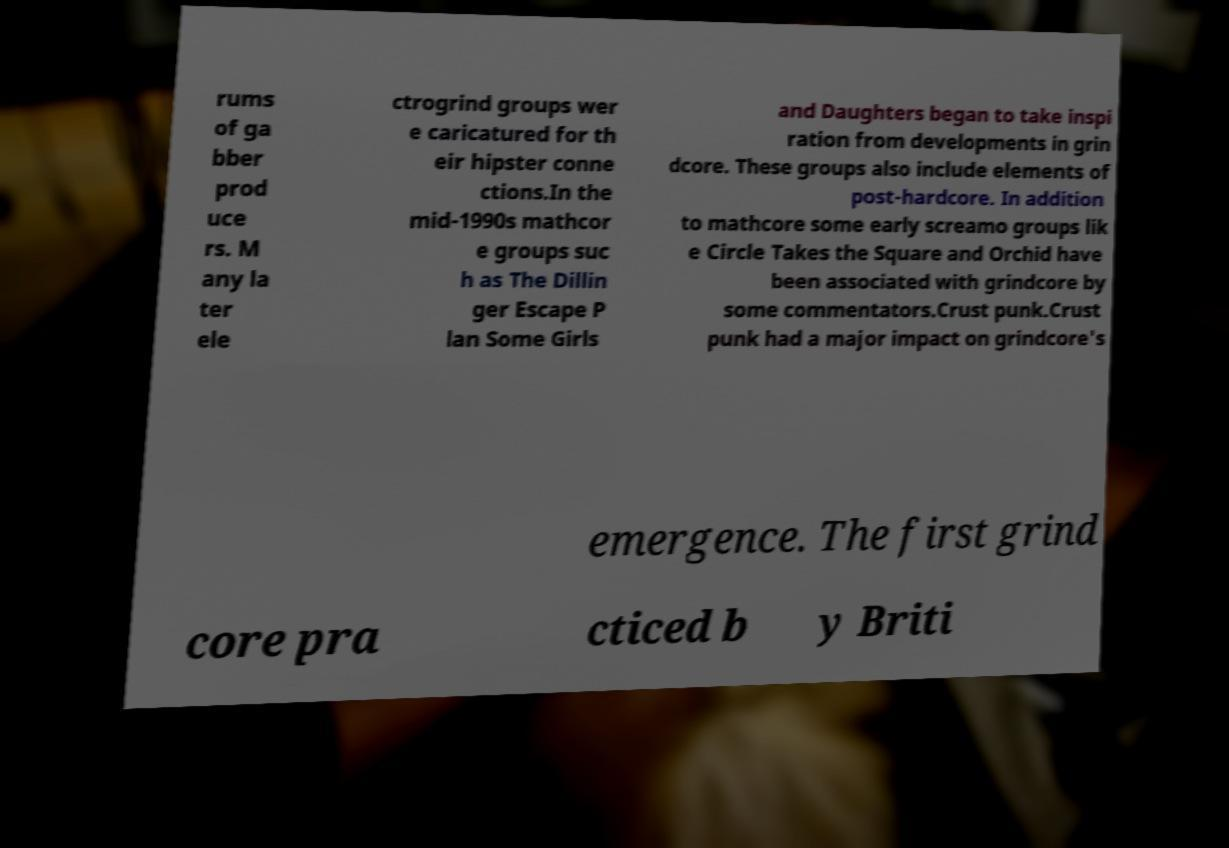Could you extract and type out the text from this image? rums of ga bber prod uce rs. M any la ter ele ctrogrind groups wer e caricatured for th eir hipster conne ctions.In the mid-1990s mathcor e groups suc h as The Dillin ger Escape P lan Some Girls and Daughters began to take inspi ration from developments in grin dcore. These groups also include elements of post-hardcore. In addition to mathcore some early screamo groups lik e Circle Takes the Square and Orchid have been associated with grindcore by some commentators.Crust punk.Crust punk had a major impact on grindcore's emergence. The first grind core pra cticed b y Briti 